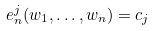<formula> <loc_0><loc_0><loc_500><loc_500>e _ { n } ^ { j } ( w _ { 1 } , \dots , w _ { n } ) = c _ { j }</formula> 